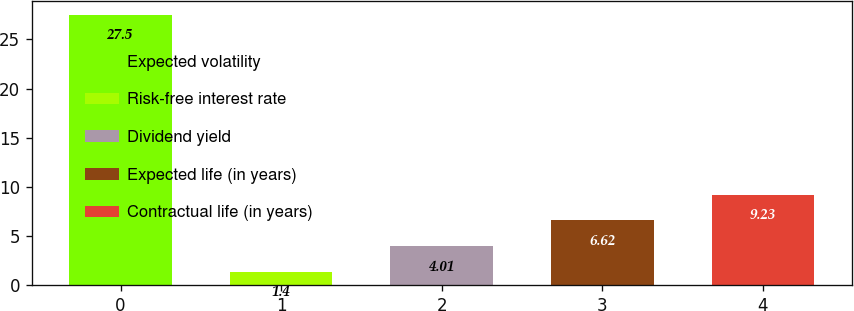Convert chart. <chart><loc_0><loc_0><loc_500><loc_500><bar_chart><fcel>Expected volatility<fcel>Risk-free interest rate<fcel>Dividend yield<fcel>Expected life (in years)<fcel>Contractual life (in years)<nl><fcel>27.5<fcel>1.4<fcel>4.01<fcel>6.62<fcel>9.23<nl></chart> 